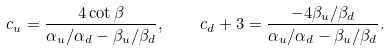<formula> <loc_0><loc_0><loc_500><loc_500>c _ { u } = \frac { 4 \cot \beta } { \alpha _ { u } / \alpha _ { d } - \beta _ { u } / \beta _ { d } } , \quad c _ { d } + 3 = \frac { - 4 \beta _ { u } / \beta _ { d } } { \alpha _ { u } / \alpha _ { d } - \beta _ { u } / \beta _ { d } } .</formula> 